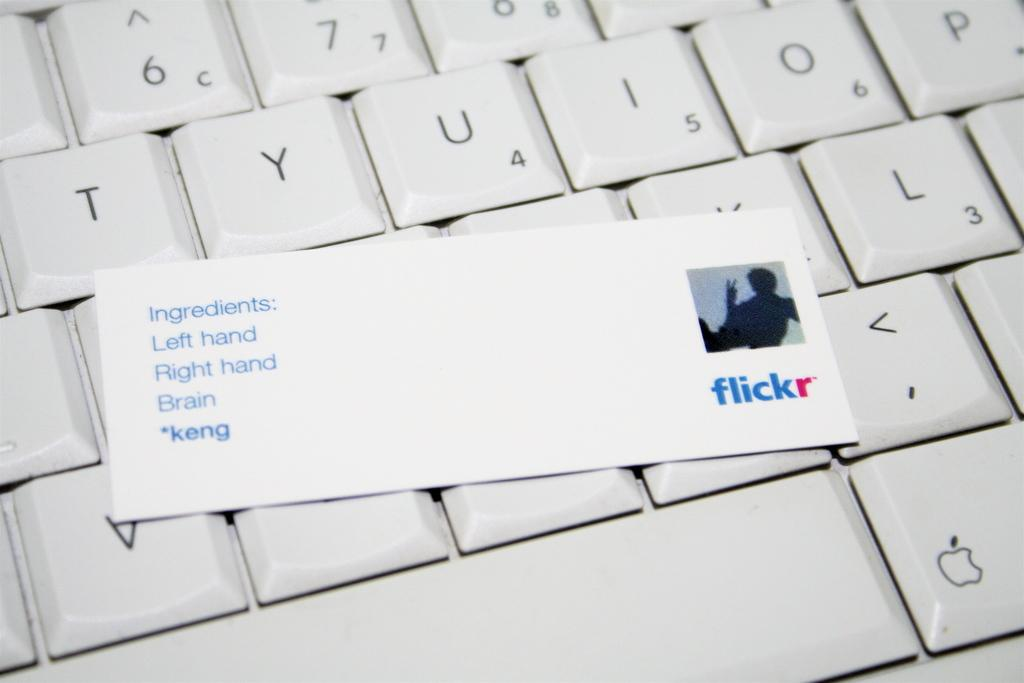Provide a one-sentence caption for the provided image. A card for flickr says Ingredients: Left Hand, Right Hand, Brain, *keng and is laid on top of a keyboard. 